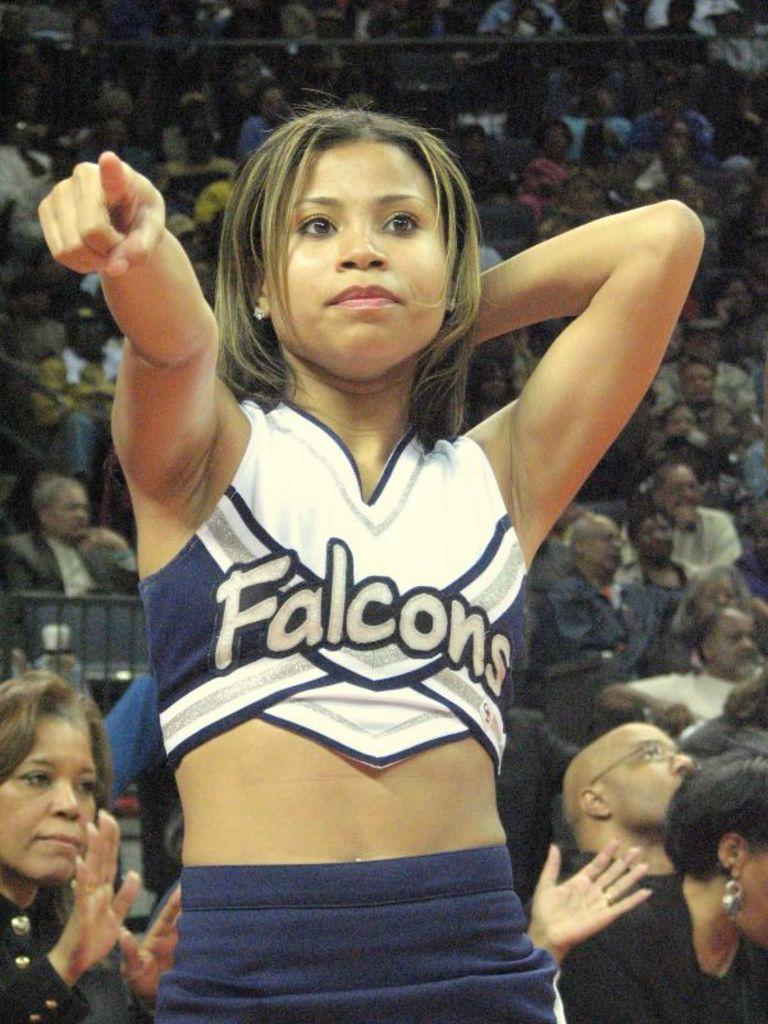<image>
Summarize the visual content of the image. A cheerleader wearing a Falcons uniform standing in front of a crowd. 